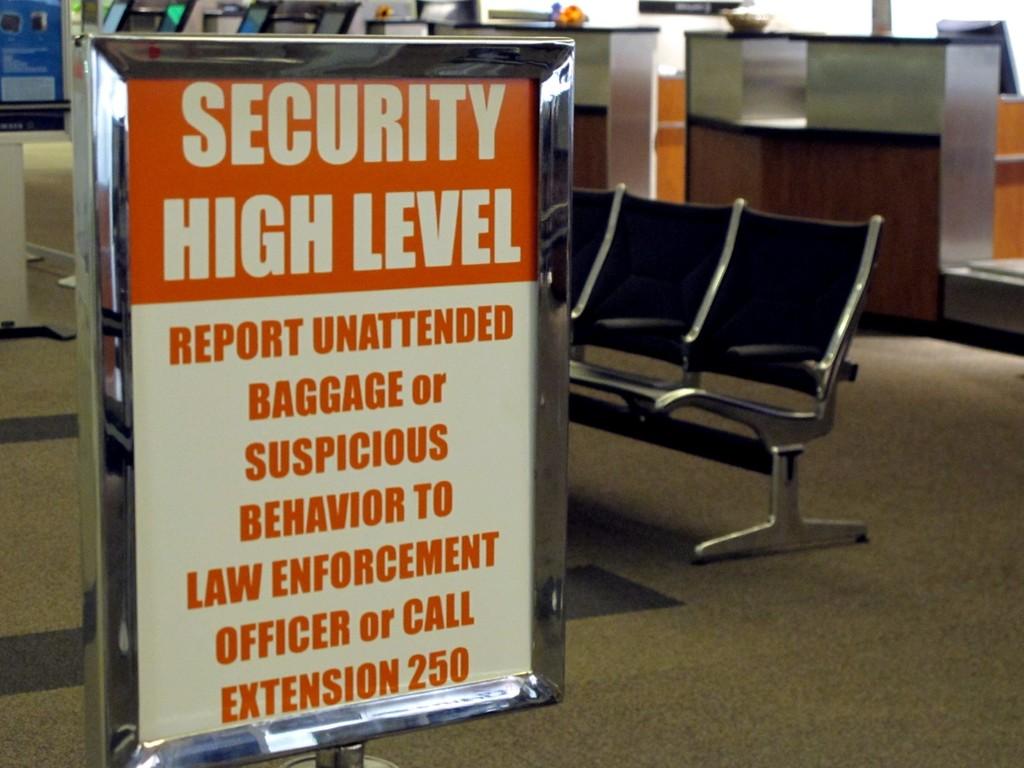How high is the security level in this airport?
Offer a very short reply. High. What should be reported?
Your response must be concise. Unattended baggage or suspicious behavior. 